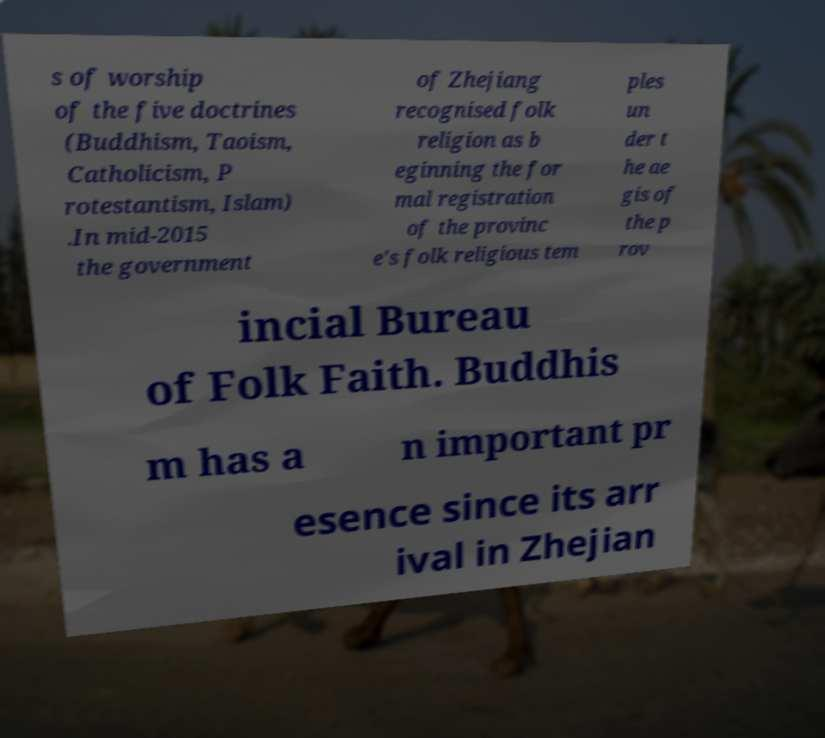There's text embedded in this image that I need extracted. Can you transcribe it verbatim? s of worship of the five doctrines (Buddhism, Taoism, Catholicism, P rotestantism, Islam) .In mid-2015 the government of Zhejiang recognised folk religion as b eginning the for mal registration of the provinc e's folk religious tem ples un der t he ae gis of the p rov incial Bureau of Folk Faith. Buddhis m has a n important pr esence since its arr ival in Zhejian 